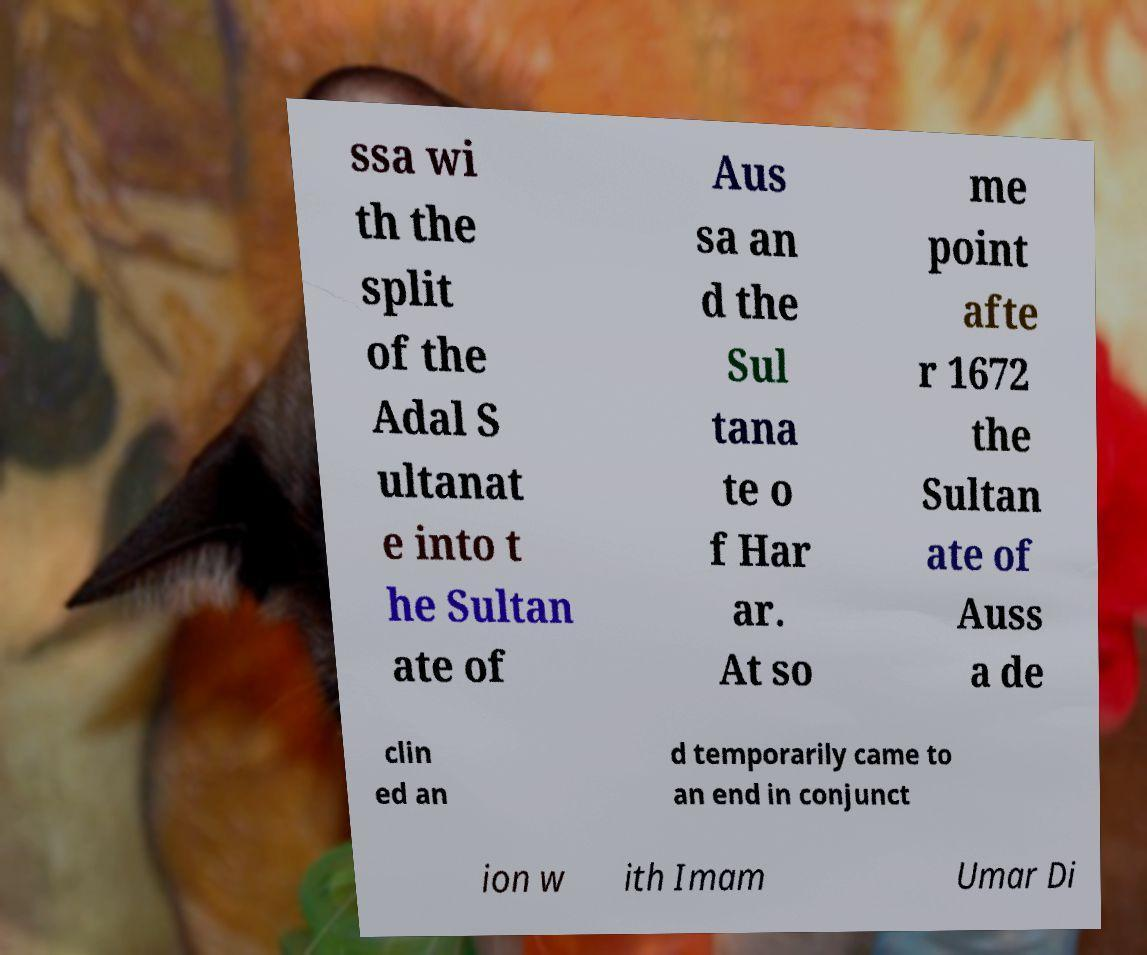Please read and relay the text visible in this image. What does it say? ssa wi th the split of the Adal S ultanat e into t he Sultan ate of Aus sa an d the Sul tana te o f Har ar. At so me point afte r 1672 the Sultan ate of Auss a de clin ed an d temporarily came to an end in conjunct ion w ith Imam Umar Di 